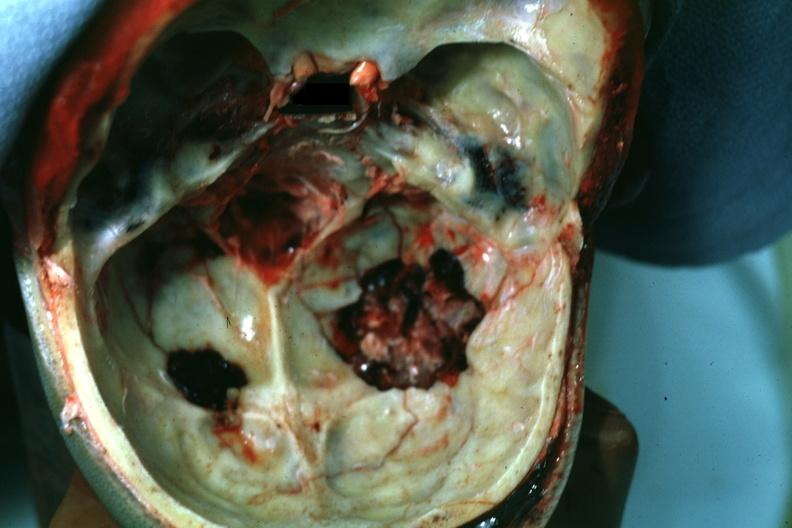what looks more like a gunshot wound?
Answer the question using a single word or phrase. This 